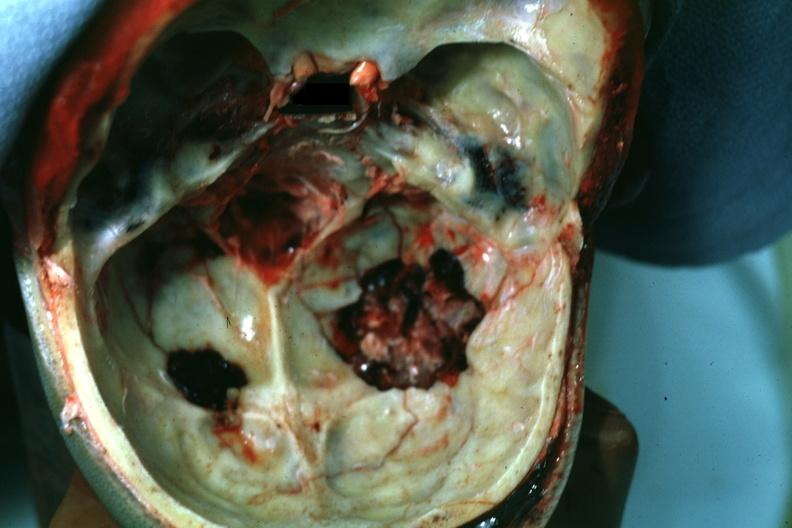what looks more like a gunshot wound?
Answer the question using a single word or phrase. This 